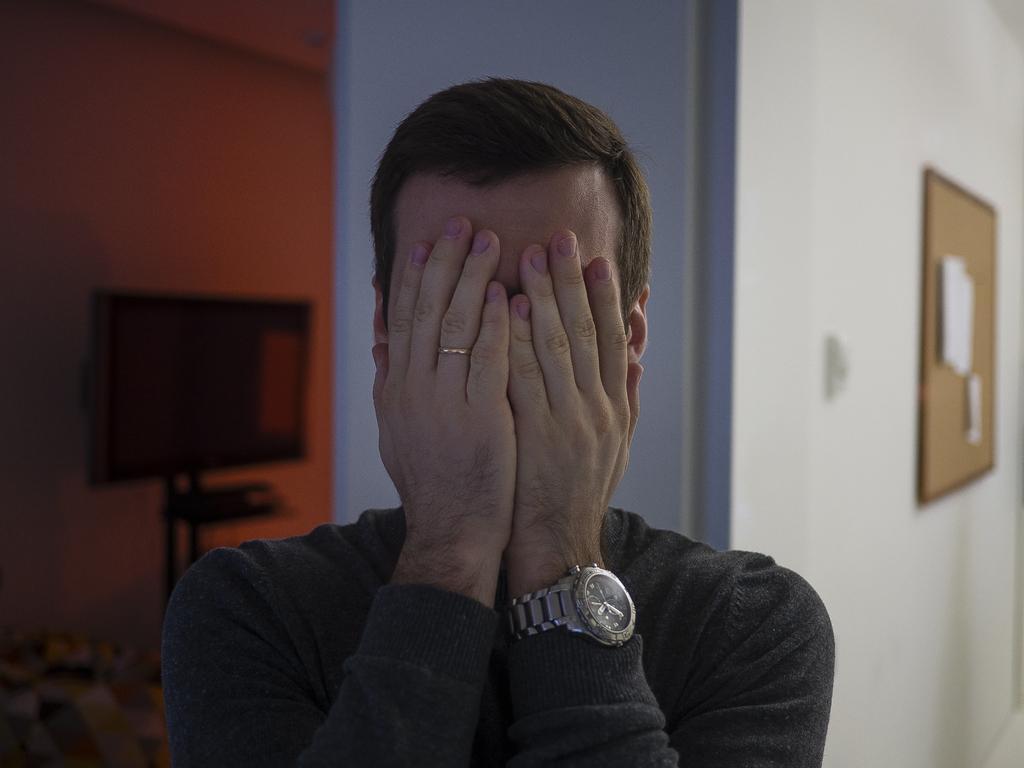In one or two sentences, can you explain what this image depicts? In this picture I can see there is a man standing and covering his face with both of his hands and in the backdrop I can see there is a all and a television is attached to the wall and there is a board attached to the wall on the right side. 